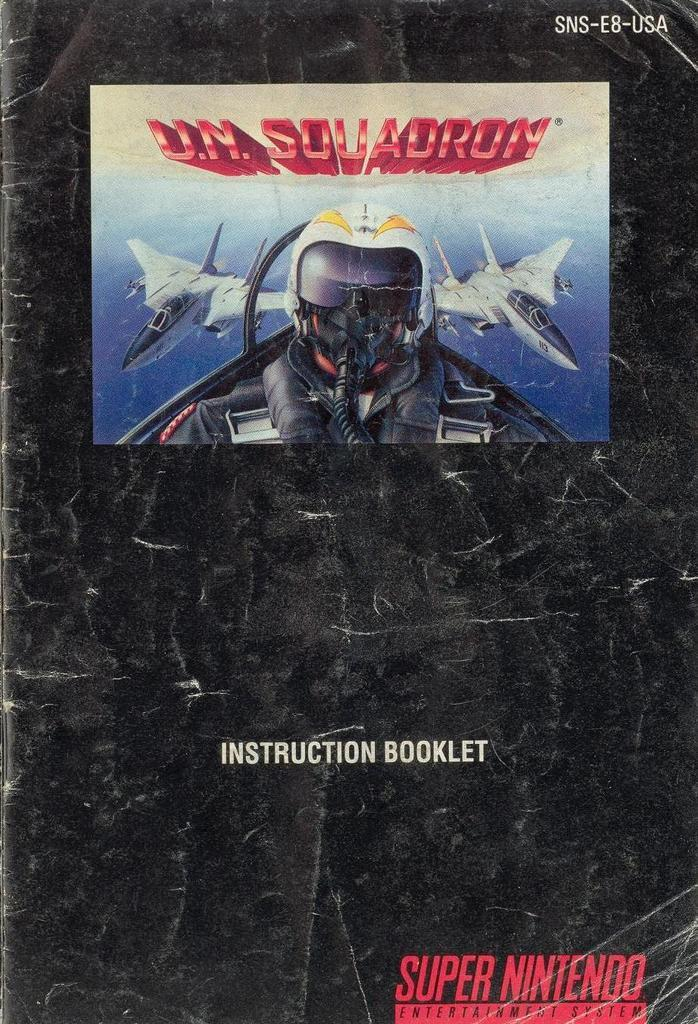Provide a one-sentence caption for the provided image. A super nintendo instruction manual for the game U.N. Squadron. 